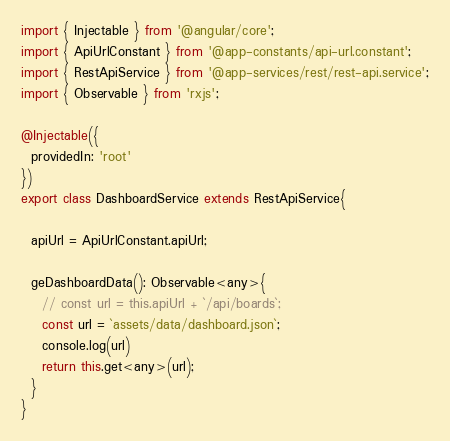Convert code to text. <code><loc_0><loc_0><loc_500><loc_500><_TypeScript_>import { Injectable } from '@angular/core';
import { ApiUrlConstant } from '@app-constants/api-url.constant';
import { RestApiService } from '@app-services/rest/rest-api.service';
import { Observable } from 'rxjs';

@Injectable({
  providedIn: 'root'
})
export class DashboardService extends RestApiService{

  apiUrl = ApiUrlConstant.apiUrl;

  geDashboardData(): Observable<any>{
    // const url = this.apiUrl + `/api/boards`;
    const url = `assets/data/dashboard.json`;
    console.log(url)
    return this.get<any>(url);
  }
}
</code> 